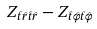<formula> <loc_0><loc_0><loc_500><loc_500>Z _ { \hat { t } \hat { r } \hat { t } \hat { r } } - Z _ { \hat { t } \hat { \varphi } \hat { t } \hat { \varphi } }</formula> 